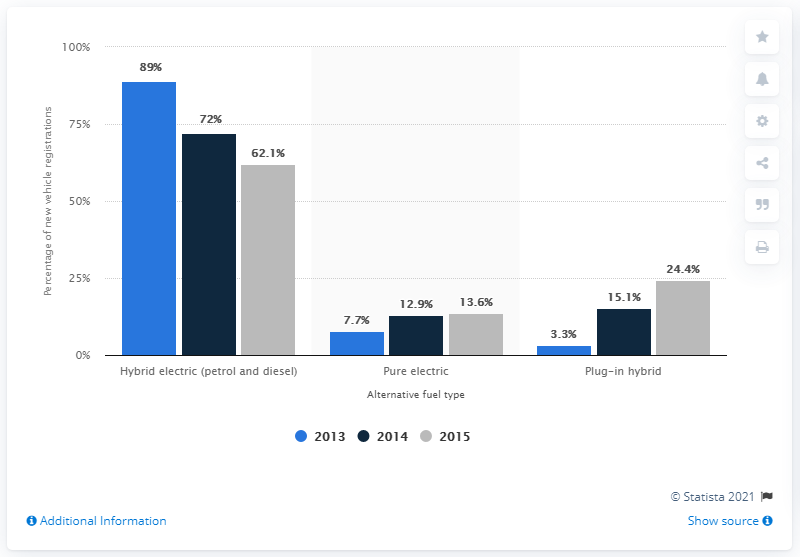Point out several critical features in this image. The use of alternative fuel in new cars registered in the UK was introduced in the year 2014. In 2015, plug-in hybrids accounted for 24.4% of the UK vehicle market. In 2013, the share of plug-in hybrids on the vehicle market was 3.3%. 